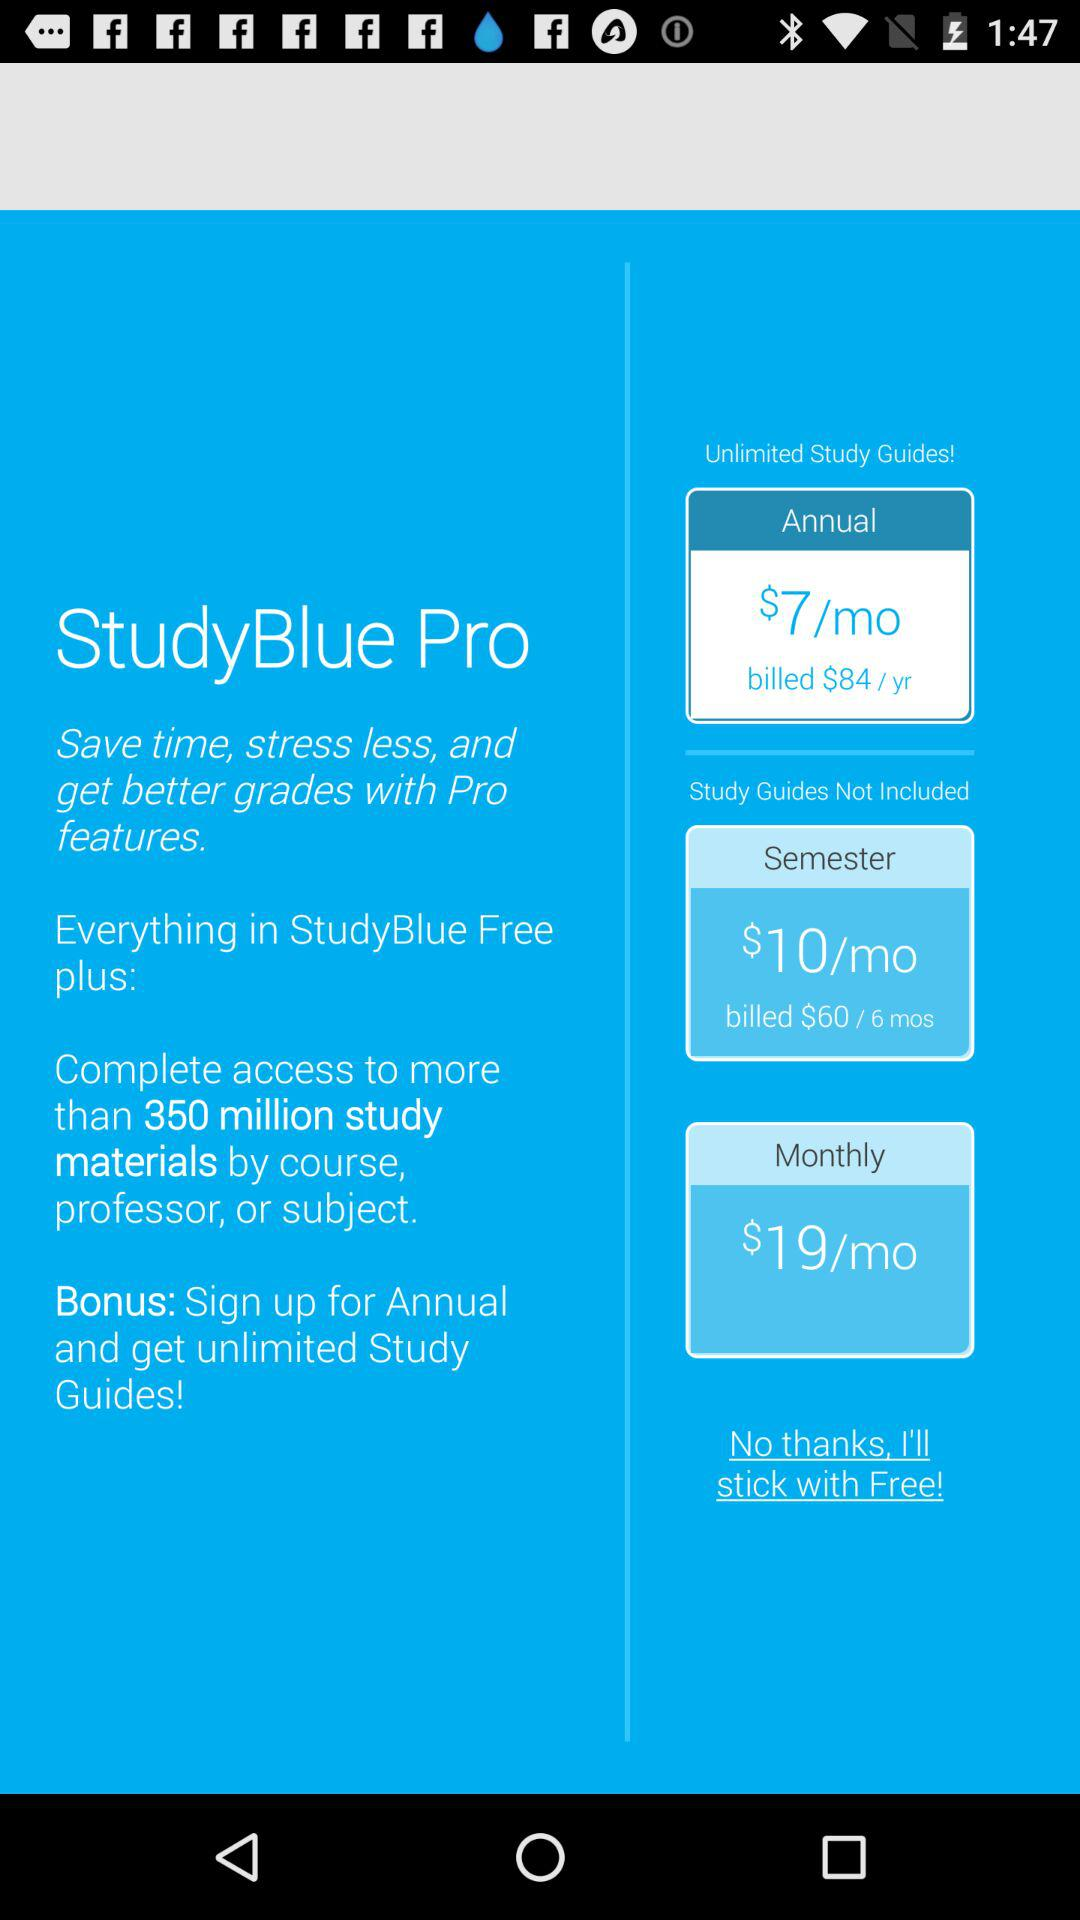How much is the price for the annual guide per year? The price is $84 per year. 